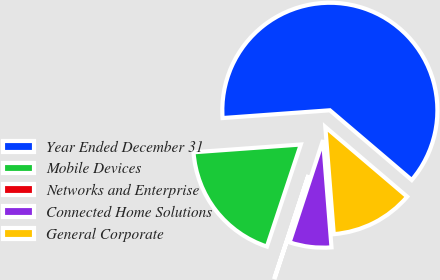Convert chart. <chart><loc_0><loc_0><loc_500><loc_500><pie_chart><fcel>Year Ended December 31<fcel>Mobile Devices<fcel>Networks and Enterprise<fcel>Connected Home Solutions<fcel>General Corporate<nl><fcel>62.37%<fcel>18.75%<fcel>0.06%<fcel>6.29%<fcel>12.52%<nl></chart> 